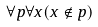Convert formula to latex. <formula><loc_0><loc_0><loc_500><loc_500>\forall p \forall x ( x \notin p )</formula> 